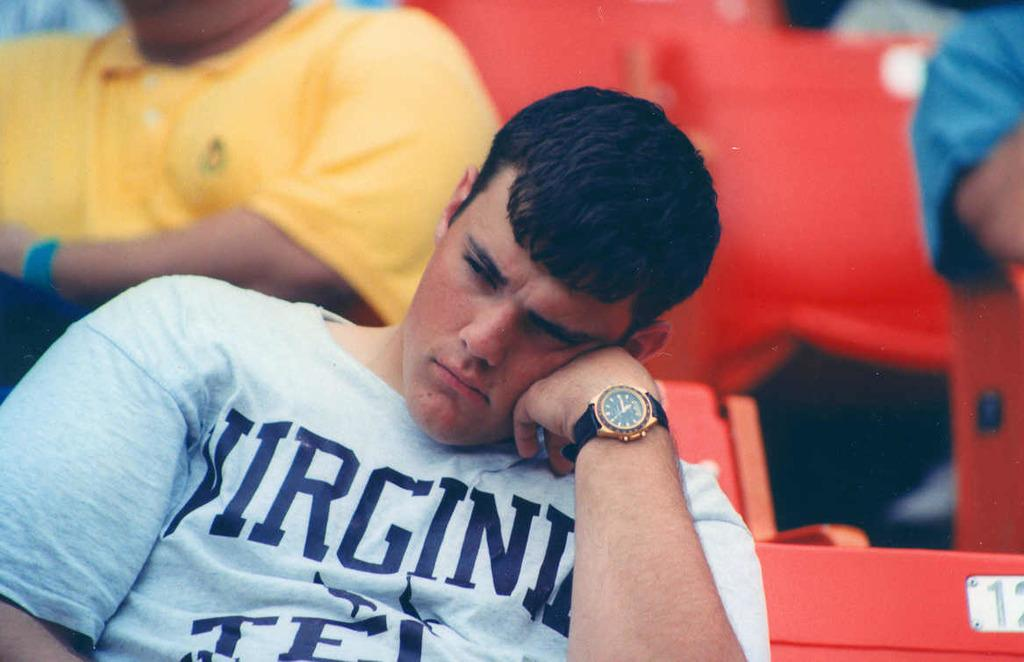<image>
Write a terse but informative summary of the picture. A college kid wearing a shirt that says Virginia on it. 